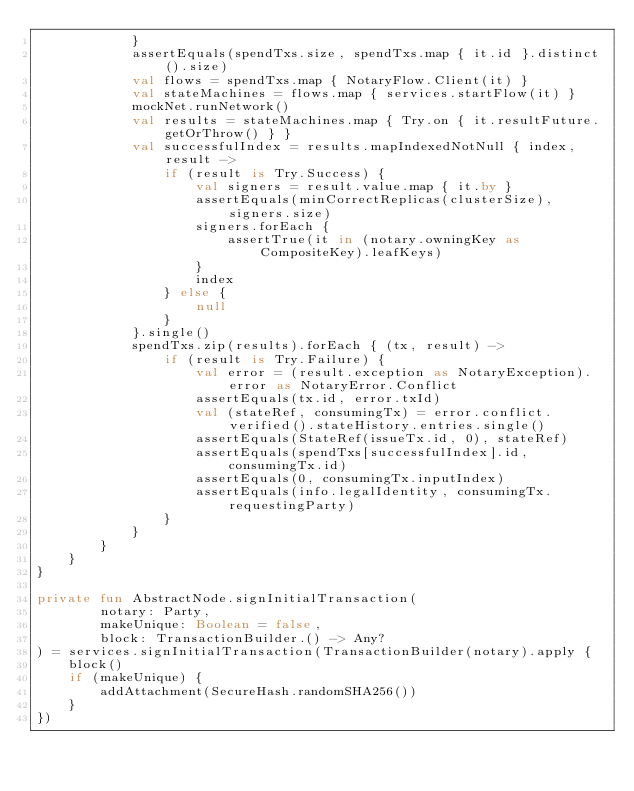<code> <loc_0><loc_0><loc_500><loc_500><_Kotlin_>            }
            assertEquals(spendTxs.size, spendTxs.map { it.id }.distinct().size)
            val flows = spendTxs.map { NotaryFlow.Client(it) }
            val stateMachines = flows.map { services.startFlow(it) }
            mockNet.runNetwork()
            val results = stateMachines.map { Try.on { it.resultFuture.getOrThrow() } }
            val successfulIndex = results.mapIndexedNotNull { index, result ->
                if (result is Try.Success) {
                    val signers = result.value.map { it.by }
                    assertEquals(minCorrectReplicas(clusterSize), signers.size)
                    signers.forEach {
                        assertTrue(it in (notary.owningKey as CompositeKey).leafKeys)
                    }
                    index
                } else {
                    null
                }
            }.single()
            spendTxs.zip(results).forEach { (tx, result) ->
                if (result is Try.Failure) {
                    val error = (result.exception as NotaryException).error as NotaryError.Conflict
                    assertEquals(tx.id, error.txId)
                    val (stateRef, consumingTx) = error.conflict.verified().stateHistory.entries.single()
                    assertEquals(StateRef(issueTx.id, 0), stateRef)
                    assertEquals(spendTxs[successfulIndex].id, consumingTx.id)
                    assertEquals(0, consumingTx.inputIndex)
                    assertEquals(info.legalIdentity, consumingTx.requestingParty)
                }
            }
        }
    }
}

private fun AbstractNode.signInitialTransaction(
        notary: Party,
        makeUnique: Boolean = false,
        block: TransactionBuilder.() -> Any?
) = services.signInitialTransaction(TransactionBuilder(notary).apply {
    block()
    if (makeUnique) {
        addAttachment(SecureHash.randomSHA256())
    }
})
</code> 